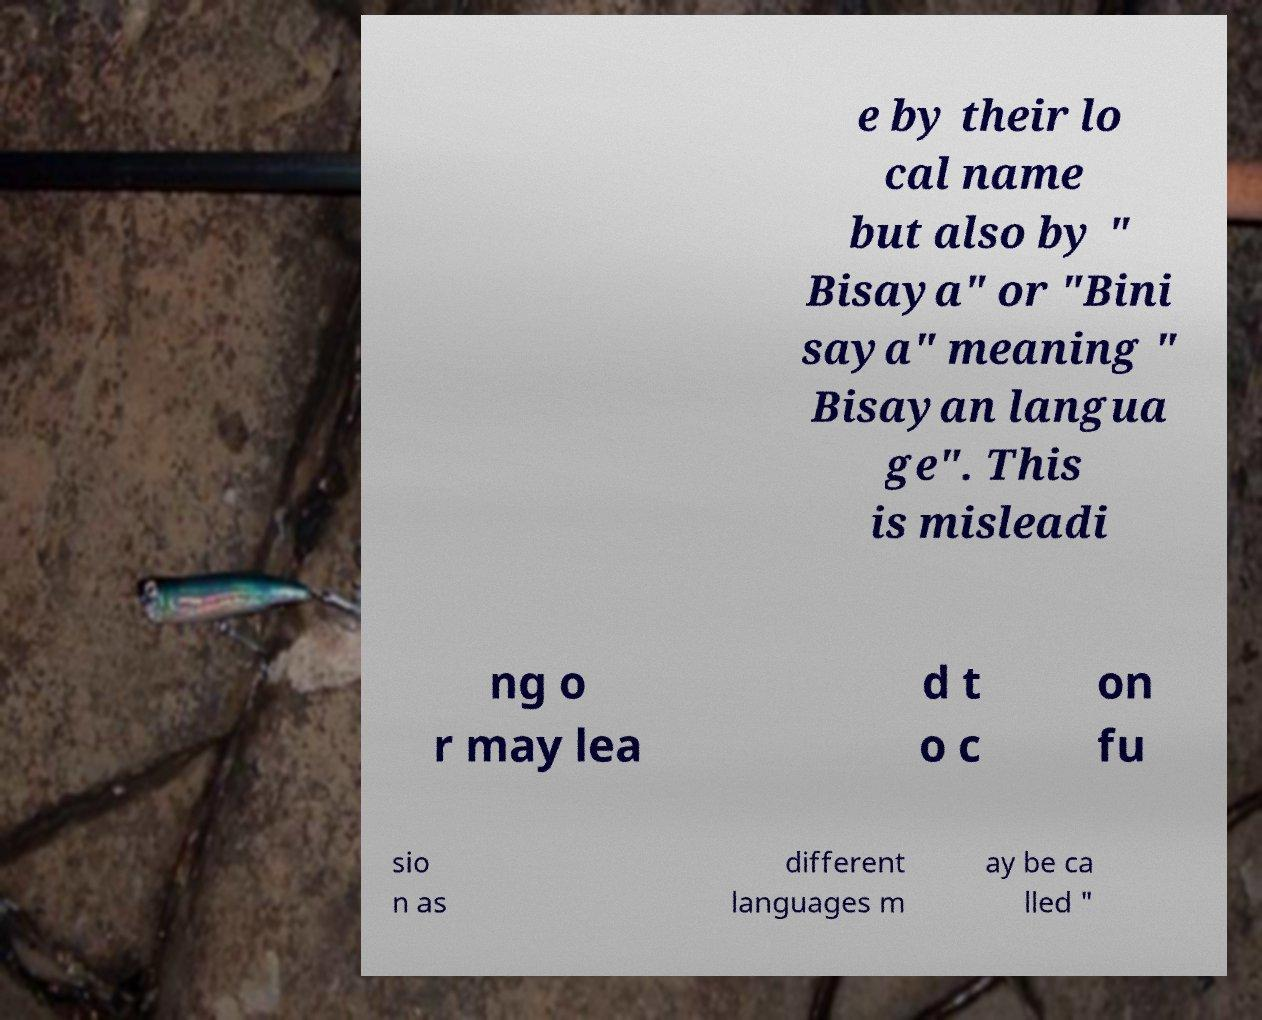Please read and relay the text visible in this image. What does it say? e by their lo cal name but also by " Bisaya" or "Bini saya" meaning " Bisayan langua ge". This is misleadi ng o r may lea d t o c on fu sio n as different languages m ay be ca lled " 